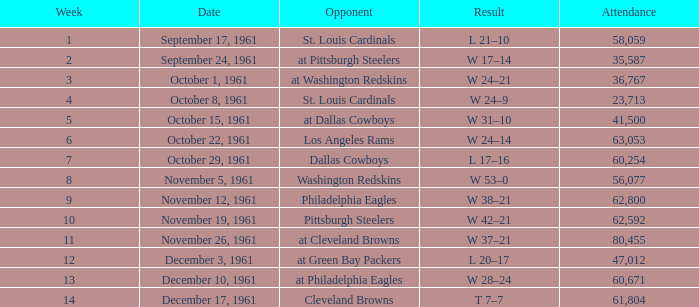What was the result on october 8, 1961? W 24–9. 